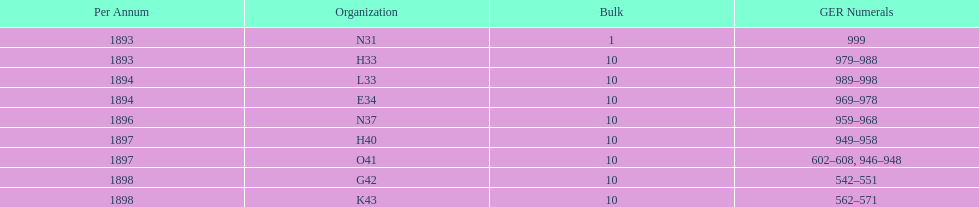Which year had the least ger numbers? 1893. 